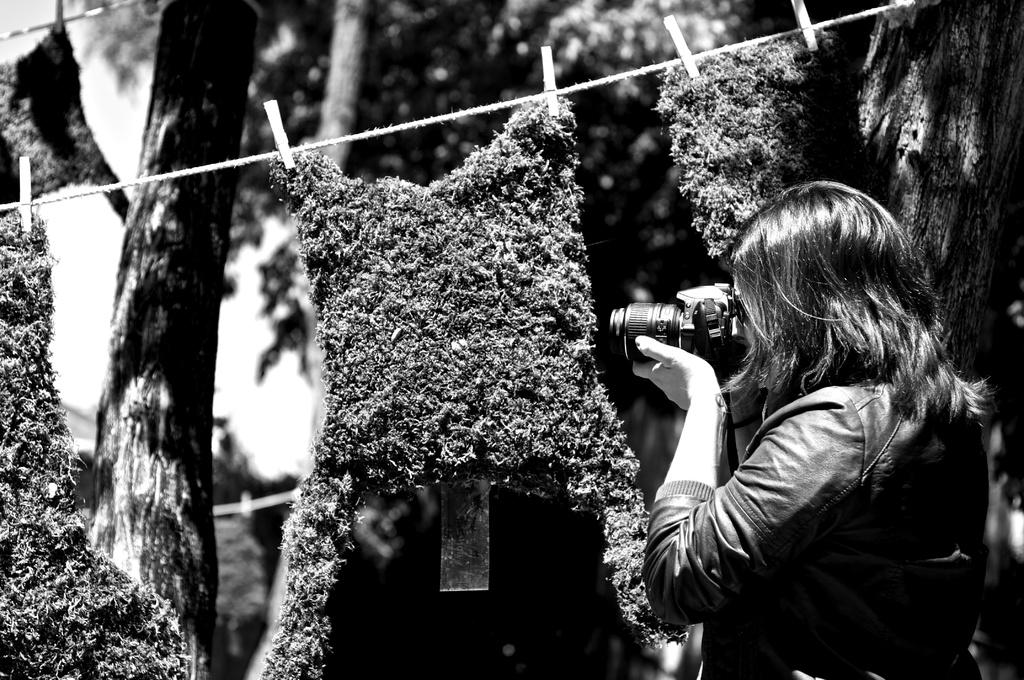What is the color scheme of the image? The image is black and white. Can you describe the main subject of the image? There is a person in the image. What object is associated with the person in the image? There is a camera in the image. What other object can be seen in the image? There is a rope in the image. What is visible in the background of the image? There are trees and the sky in the background of the image. How many other objects can be seen in the image? There are other objects in the image, but the exact number is not specified. How many nuts are being cracked by the person in the image? There are no nuts present in the image. Can you describe the visitor in the image? There is no visitor mentioned or depicted in the image. 